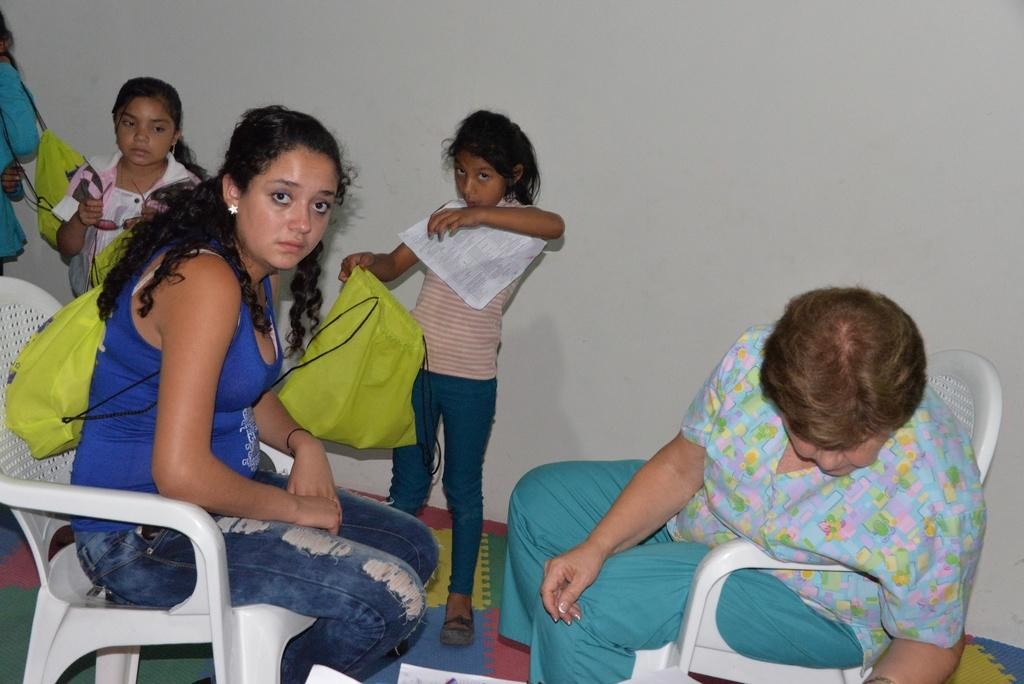How many people are sitting on chairs in the image? There are two people sitting on chairs in the image. What can be seen in the background of the image? In the background of the image, there is a person, two girls, bags, paper, goggles, and a wall. Can you describe the people in the background? There is one person and two girls in the background of the image. What objects are present in the background of the image? In the background of the image, there are bags, paper, and goggles. What type of structure is visible in the background of the image? There is a wall visible in the background of the image. How many boys are present in the image? There is no information about boys in the image; it only mentions two people sitting on chairs and various objects in the background. What type of drug can be seen in the image? There is no drug present in the image; it features people sitting on chairs and objects in the background. 